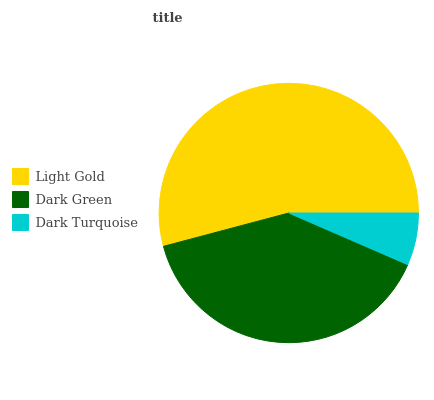Is Dark Turquoise the minimum?
Answer yes or no. Yes. Is Light Gold the maximum?
Answer yes or no. Yes. Is Dark Green the minimum?
Answer yes or no. No. Is Dark Green the maximum?
Answer yes or no. No. Is Light Gold greater than Dark Green?
Answer yes or no. Yes. Is Dark Green less than Light Gold?
Answer yes or no. Yes. Is Dark Green greater than Light Gold?
Answer yes or no. No. Is Light Gold less than Dark Green?
Answer yes or no. No. Is Dark Green the high median?
Answer yes or no. Yes. Is Dark Green the low median?
Answer yes or no. Yes. Is Light Gold the high median?
Answer yes or no. No. Is Light Gold the low median?
Answer yes or no. No. 